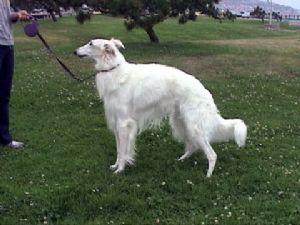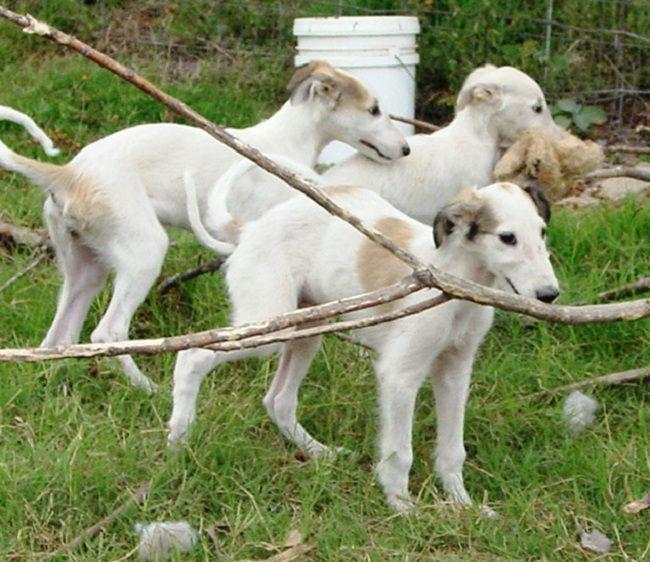The first image is the image on the left, the second image is the image on the right. Given the left and right images, does the statement "A dog is being touched by a human in one of the images." hold true? Answer yes or no. No. The first image is the image on the left, the second image is the image on the right. Evaluate the accuracy of this statement regarding the images: "A person is standing in the center of the scene, interacting with at least one all-white dog.". Is it true? Answer yes or no. No. 